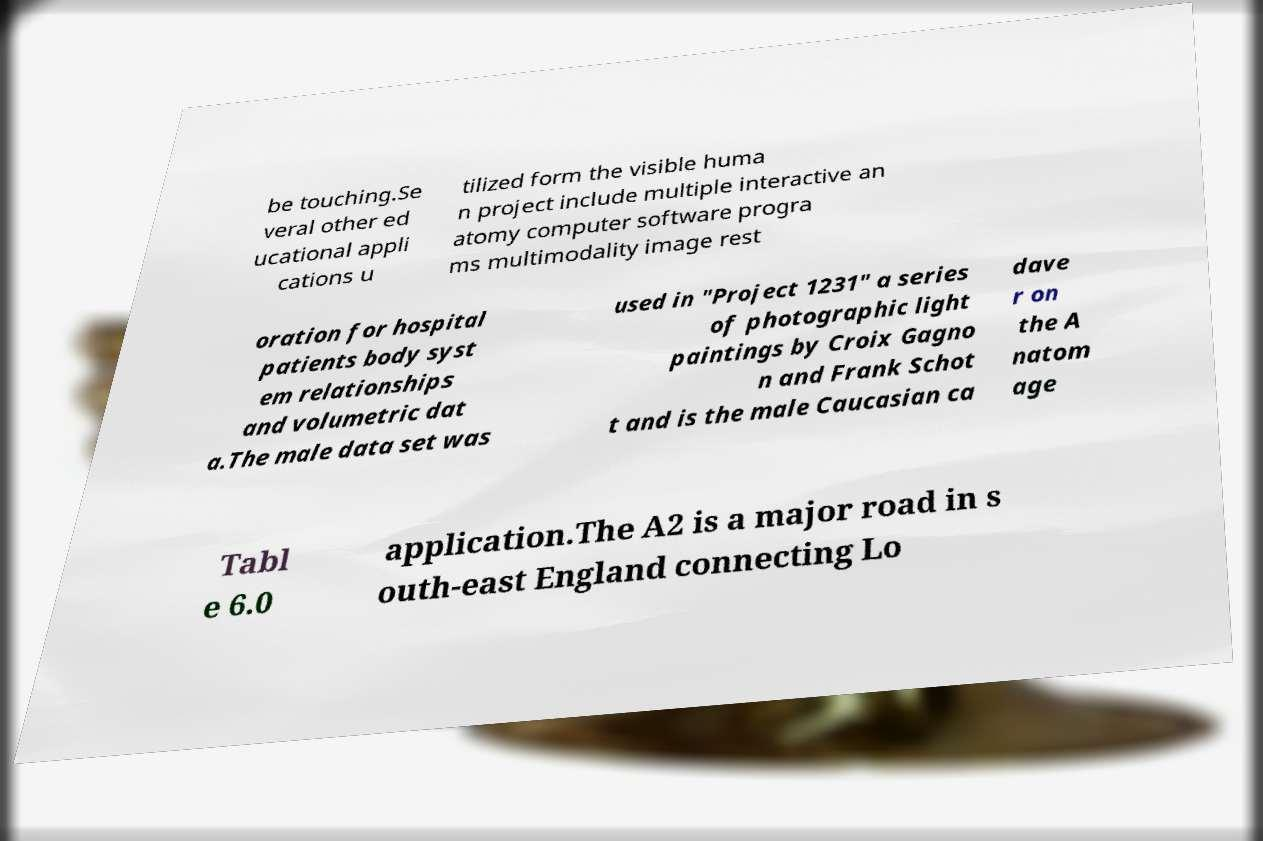Please identify and transcribe the text found in this image. be touching.Se veral other ed ucational appli cations u tilized form the visible huma n project include multiple interactive an atomy computer software progra ms multimodality image rest oration for hospital patients body syst em relationships and volumetric dat a.The male data set was used in "Project 1231" a series of photographic light paintings by Croix Gagno n and Frank Schot t and is the male Caucasian ca dave r on the A natom age Tabl e 6.0 application.The A2 is a major road in s outh-east England connecting Lo 